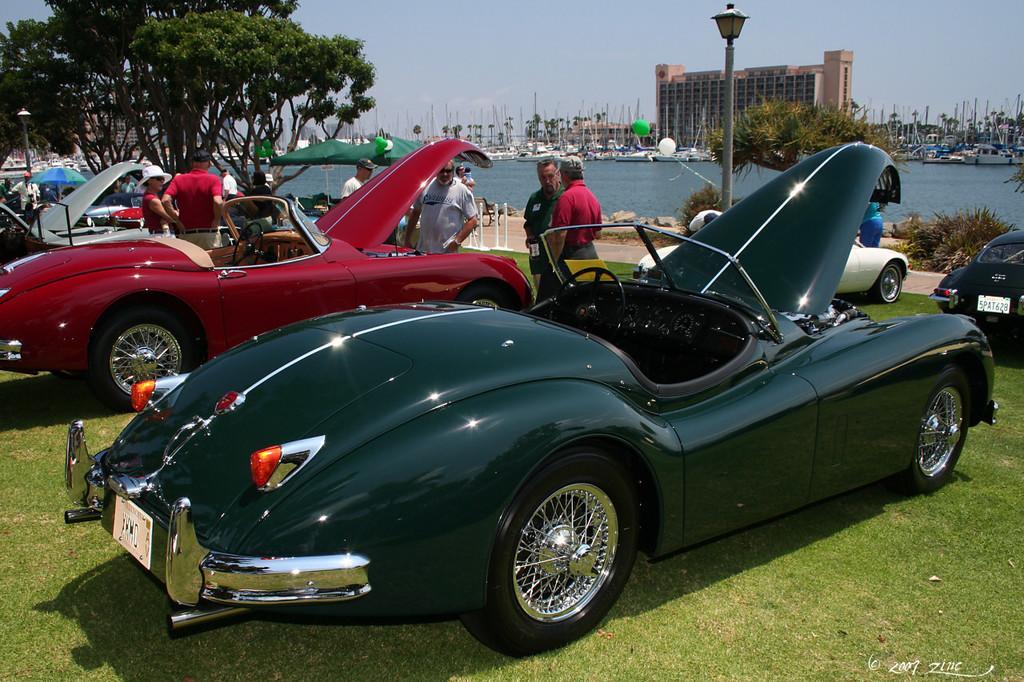In one or two sentences, can you explain what this image depicts? In this picture we can see some grass on the ground. There are vehicles, a few people, street lights, trees, poles and boats on the water. We can see an umbrella, a building, other objects and the sky. There is a watermark, numbers and the text in the bottom right. 